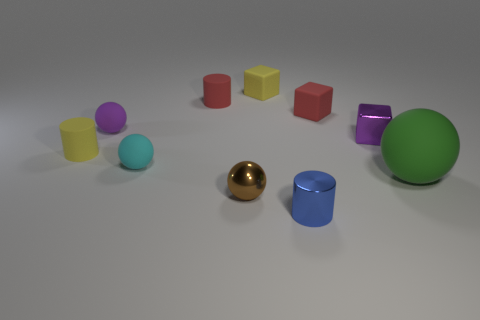There is a tiny cyan matte thing; is its shape the same as the purple thing to the left of the tiny brown shiny thing?
Offer a terse response. Yes. Is there a matte object of the same color as the shiny block?
Provide a succinct answer. Yes. What size is the green ball that is the same material as the small purple sphere?
Your answer should be very brief. Large. There is a tiny red matte object that is right of the tiny brown thing; does it have the same shape as the large thing?
Offer a terse response. No. How many other things are the same size as the blue object?
Provide a short and direct response. 8. What shape is the matte object that is the same color as the tiny shiny block?
Provide a short and direct response. Sphere. Are there any tiny purple objects that are right of the small yellow thing right of the red rubber cylinder?
Your answer should be very brief. Yes. How many objects are small objects that are to the left of the metal cube or small metallic cubes?
Give a very brief answer. 9. What number of big matte spheres are there?
Provide a succinct answer. 1. There is a blue thing that is the same material as the small brown thing; what shape is it?
Provide a succinct answer. Cylinder. 